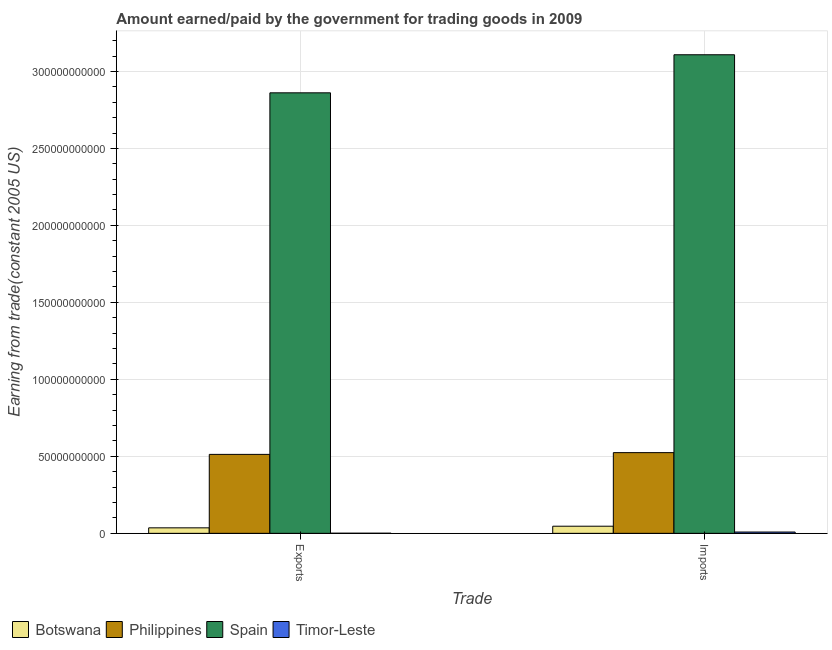How many different coloured bars are there?
Your answer should be very brief. 4. Are the number of bars per tick equal to the number of legend labels?
Ensure brevity in your answer.  Yes. Are the number of bars on each tick of the X-axis equal?
Provide a succinct answer. Yes. How many bars are there on the 2nd tick from the right?
Make the answer very short. 4. What is the label of the 2nd group of bars from the left?
Your response must be concise. Imports. What is the amount earned from exports in Botswana?
Your answer should be compact. 3.57e+09. Across all countries, what is the maximum amount paid for imports?
Keep it short and to the point. 3.11e+11. Across all countries, what is the minimum amount earned from exports?
Ensure brevity in your answer.  6.42e+07. In which country was the amount earned from exports maximum?
Give a very brief answer. Spain. In which country was the amount paid for imports minimum?
Offer a very short reply. Timor-Leste. What is the total amount earned from exports in the graph?
Provide a short and direct response. 3.41e+11. What is the difference between the amount paid for imports in Timor-Leste and that in Botswana?
Offer a terse response. -3.77e+09. What is the difference between the amount earned from exports in Timor-Leste and the amount paid for imports in Philippines?
Offer a very short reply. -5.24e+1. What is the average amount earned from exports per country?
Offer a very short reply. 8.53e+1. What is the difference between the amount earned from exports and amount paid for imports in Botswana?
Keep it short and to the point. -1.05e+09. What is the ratio of the amount paid for imports in Philippines to that in Spain?
Offer a terse response. 0.17. Is the amount paid for imports in Botswana less than that in Philippines?
Your answer should be very brief. Yes. In how many countries, is the amount earned from exports greater than the average amount earned from exports taken over all countries?
Give a very brief answer. 1. What does the 4th bar from the left in Imports represents?
Make the answer very short. Timor-Leste. Are all the bars in the graph horizontal?
Your answer should be compact. No. How many countries are there in the graph?
Make the answer very short. 4. Are the values on the major ticks of Y-axis written in scientific E-notation?
Make the answer very short. No. Does the graph contain any zero values?
Ensure brevity in your answer.  No. Does the graph contain grids?
Keep it short and to the point. Yes. How are the legend labels stacked?
Offer a terse response. Horizontal. What is the title of the graph?
Ensure brevity in your answer.  Amount earned/paid by the government for trading goods in 2009. What is the label or title of the X-axis?
Give a very brief answer. Trade. What is the label or title of the Y-axis?
Ensure brevity in your answer.  Earning from trade(constant 2005 US). What is the Earning from trade(constant 2005 US) of Botswana in Exports?
Make the answer very short. 3.57e+09. What is the Earning from trade(constant 2005 US) in Philippines in Exports?
Keep it short and to the point. 5.13e+1. What is the Earning from trade(constant 2005 US) of Spain in Exports?
Offer a very short reply. 2.86e+11. What is the Earning from trade(constant 2005 US) of Timor-Leste in Exports?
Provide a succinct answer. 6.42e+07. What is the Earning from trade(constant 2005 US) of Botswana in Imports?
Your answer should be very brief. 4.63e+09. What is the Earning from trade(constant 2005 US) of Philippines in Imports?
Give a very brief answer. 5.24e+1. What is the Earning from trade(constant 2005 US) of Spain in Imports?
Provide a short and direct response. 3.11e+11. What is the Earning from trade(constant 2005 US) in Timor-Leste in Imports?
Provide a succinct answer. 8.54e+08. Across all Trade, what is the maximum Earning from trade(constant 2005 US) of Botswana?
Your answer should be compact. 4.63e+09. Across all Trade, what is the maximum Earning from trade(constant 2005 US) in Philippines?
Offer a very short reply. 5.24e+1. Across all Trade, what is the maximum Earning from trade(constant 2005 US) in Spain?
Provide a short and direct response. 3.11e+11. Across all Trade, what is the maximum Earning from trade(constant 2005 US) in Timor-Leste?
Give a very brief answer. 8.54e+08. Across all Trade, what is the minimum Earning from trade(constant 2005 US) of Botswana?
Your answer should be compact. 3.57e+09. Across all Trade, what is the minimum Earning from trade(constant 2005 US) of Philippines?
Provide a succinct answer. 5.13e+1. Across all Trade, what is the minimum Earning from trade(constant 2005 US) in Spain?
Give a very brief answer. 2.86e+11. Across all Trade, what is the minimum Earning from trade(constant 2005 US) in Timor-Leste?
Offer a terse response. 6.42e+07. What is the total Earning from trade(constant 2005 US) of Botswana in the graph?
Keep it short and to the point. 8.20e+09. What is the total Earning from trade(constant 2005 US) in Philippines in the graph?
Your answer should be compact. 1.04e+11. What is the total Earning from trade(constant 2005 US) in Spain in the graph?
Offer a terse response. 5.97e+11. What is the total Earning from trade(constant 2005 US) in Timor-Leste in the graph?
Your response must be concise. 9.18e+08. What is the difference between the Earning from trade(constant 2005 US) of Botswana in Exports and that in Imports?
Provide a short and direct response. -1.05e+09. What is the difference between the Earning from trade(constant 2005 US) in Philippines in Exports and that in Imports?
Your answer should be compact. -1.14e+09. What is the difference between the Earning from trade(constant 2005 US) in Spain in Exports and that in Imports?
Ensure brevity in your answer.  -2.47e+1. What is the difference between the Earning from trade(constant 2005 US) in Timor-Leste in Exports and that in Imports?
Provide a short and direct response. -7.90e+08. What is the difference between the Earning from trade(constant 2005 US) in Botswana in Exports and the Earning from trade(constant 2005 US) in Philippines in Imports?
Give a very brief answer. -4.88e+1. What is the difference between the Earning from trade(constant 2005 US) in Botswana in Exports and the Earning from trade(constant 2005 US) in Spain in Imports?
Give a very brief answer. -3.07e+11. What is the difference between the Earning from trade(constant 2005 US) in Botswana in Exports and the Earning from trade(constant 2005 US) in Timor-Leste in Imports?
Give a very brief answer. 2.72e+09. What is the difference between the Earning from trade(constant 2005 US) of Philippines in Exports and the Earning from trade(constant 2005 US) of Spain in Imports?
Your answer should be very brief. -2.60e+11. What is the difference between the Earning from trade(constant 2005 US) of Philippines in Exports and the Earning from trade(constant 2005 US) of Timor-Leste in Imports?
Offer a very short reply. 5.04e+1. What is the difference between the Earning from trade(constant 2005 US) in Spain in Exports and the Earning from trade(constant 2005 US) in Timor-Leste in Imports?
Offer a terse response. 2.85e+11. What is the average Earning from trade(constant 2005 US) in Botswana per Trade?
Make the answer very short. 4.10e+09. What is the average Earning from trade(constant 2005 US) of Philippines per Trade?
Ensure brevity in your answer.  5.18e+1. What is the average Earning from trade(constant 2005 US) in Spain per Trade?
Give a very brief answer. 2.98e+11. What is the average Earning from trade(constant 2005 US) of Timor-Leste per Trade?
Keep it short and to the point. 4.59e+08. What is the difference between the Earning from trade(constant 2005 US) in Botswana and Earning from trade(constant 2005 US) in Philippines in Exports?
Offer a terse response. -4.77e+1. What is the difference between the Earning from trade(constant 2005 US) in Botswana and Earning from trade(constant 2005 US) in Spain in Exports?
Ensure brevity in your answer.  -2.83e+11. What is the difference between the Earning from trade(constant 2005 US) of Botswana and Earning from trade(constant 2005 US) of Timor-Leste in Exports?
Your answer should be very brief. 3.51e+09. What is the difference between the Earning from trade(constant 2005 US) of Philippines and Earning from trade(constant 2005 US) of Spain in Exports?
Ensure brevity in your answer.  -2.35e+11. What is the difference between the Earning from trade(constant 2005 US) in Philippines and Earning from trade(constant 2005 US) in Timor-Leste in Exports?
Your answer should be compact. 5.12e+1. What is the difference between the Earning from trade(constant 2005 US) in Spain and Earning from trade(constant 2005 US) in Timor-Leste in Exports?
Make the answer very short. 2.86e+11. What is the difference between the Earning from trade(constant 2005 US) of Botswana and Earning from trade(constant 2005 US) of Philippines in Imports?
Provide a succinct answer. -4.78e+1. What is the difference between the Earning from trade(constant 2005 US) in Botswana and Earning from trade(constant 2005 US) in Spain in Imports?
Make the answer very short. -3.06e+11. What is the difference between the Earning from trade(constant 2005 US) of Botswana and Earning from trade(constant 2005 US) of Timor-Leste in Imports?
Provide a succinct answer. 3.77e+09. What is the difference between the Earning from trade(constant 2005 US) in Philippines and Earning from trade(constant 2005 US) in Spain in Imports?
Keep it short and to the point. -2.58e+11. What is the difference between the Earning from trade(constant 2005 US) of Philippines and Earning from trade(constant 2005 US) of Timor-Leste in Imports?
Your response must be concise. 5.16e+1. What is the difference between the Earning from trade(constant 2005 US) of Spain and Earning from trade(constant 2005 US) of Timor-Leste in Imports?
Ensure brevity in your answer.  3.10e+11. What is the ratio of the Earning from trade(constant 2005 US) in Botswana in Exports to that in Imports?
Your response must be concise. 0.77. What is the ratio of the Earning from trade(constant 2005 US) in Philippines in Exports to that in Imports?
Keep it short and to the point. 0.98. What is the ratio of the Earning from trade(constant 2005 US) in Spain in Exports to that in Imports?
Provide a short and direct response. 0.92. What is the ratio of the Earning from trade(constant 2005 US) of Timor-Leste in Exports to that in Imports?
Your answer should be very brief. 0.08. What is the difference between the highest and the second highest Earning from trade(constant 2005 US) of Botswana?
Offer a terse response. 1.05e+09. What is the difference between the highest and the second highest Earning from trade(constant 2005 US) of Philippines?
Provide a short and direct response. 1.14e+09. What is the difference between the highest and the second highest Earning from trade(constant 2005 US) of Spain?
Make the answer very short. 2.47e+1. What is the difference between the highest and the second highest Earning from trade(constant 2005 US) of Timor-Leste?
Offer a very short reply. 7.90e+08. What is the difference between the highest and the lowest Earning from trade(constant 2005 US) in Botswana?
Offer a very short reply. 1.05e+09. What is the difference between the highest and the lowest Earning from trade(constant 2005 US) in Philippines?
Ensure brevity in your answer.  1.14e+09. What is the difference between the highest and the lowest Earning from trade(constant 2005 US) in Spain?
Your answer should be compact. 2.47e+1. What is the difference between the highest and the lowest Earning from trade(constant 2005 US) in Timor-Leste?
Ensure brevity in your answer.  7.90e+08. 